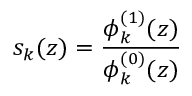Convert formula to latex. <formula><loc_0><loc_0><loc_500><loc_500>s _ { k } ( z ) = { \frac { \phi _ { k } ^ { ( 1 ) } ( z ) } { \phi _ { k } ^ { ( 0 ) } ( z ) } }</formula> 